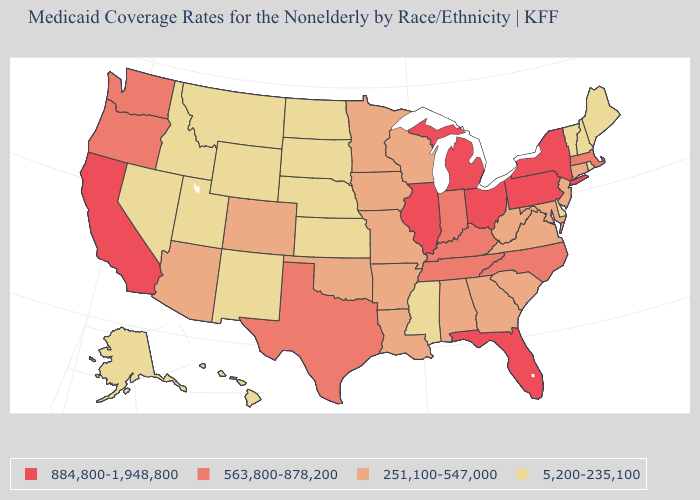Does Ohio have the same value as Nevada?
Keep it brief. No. Does West Virginia have the same value as Wyoming?
Give a very brief answer. No. Which states hav the highest value in the MidWest?
Write a very short answer. Illinois, Michigan, Ohio. Among the states that border Utah , which have the highest value?
Concise answer only. Arizona, Colorado. Does the map have missing data?
Be succinct. No. Among the states that border New Mexico , which have the highest value?
Be succinct. Texas. Which states have the lowest value in the Northeast?
Be succinct. Maine, New Hampshire, Rhode Island, Vermont. Among the states that border Georgia , which have the highest value?
Short answer required. Florida. Name the states that have a value in the range 884,800-1,948,800?
Quick response, please. California, Florida, Illinois, Michigan, New York, Ohio, Pennsylvania. Name the states that have a value in the range 563,800-878,200?
Answer briefly. Indiana, Kentucky, Massachusetts, North Carolina, Oregon, Tennessee, Texas, Washington. What is the value of Arizona?
Answer briefly. 251,100-547,000. What is the lowest value in the Northeast?
Answer briefly. 5,200-235,100. Name the states that have a value in the range 251,100-547,000?
Be succinct. Alabama, Arizona, Arkansas, Colorado, Connecticut, Georgia, Iowa, Louisiana, Maryland, Minnesota, Missouri, New Jersey, Oklahoma, South Carolina, Virginia, West Virginia, Wisconsin. What is the value of North Dakota?
Give a very brief answer. 5,200-235,100. Does Delaware have the highest value in the South?
Answer briefly. No. 